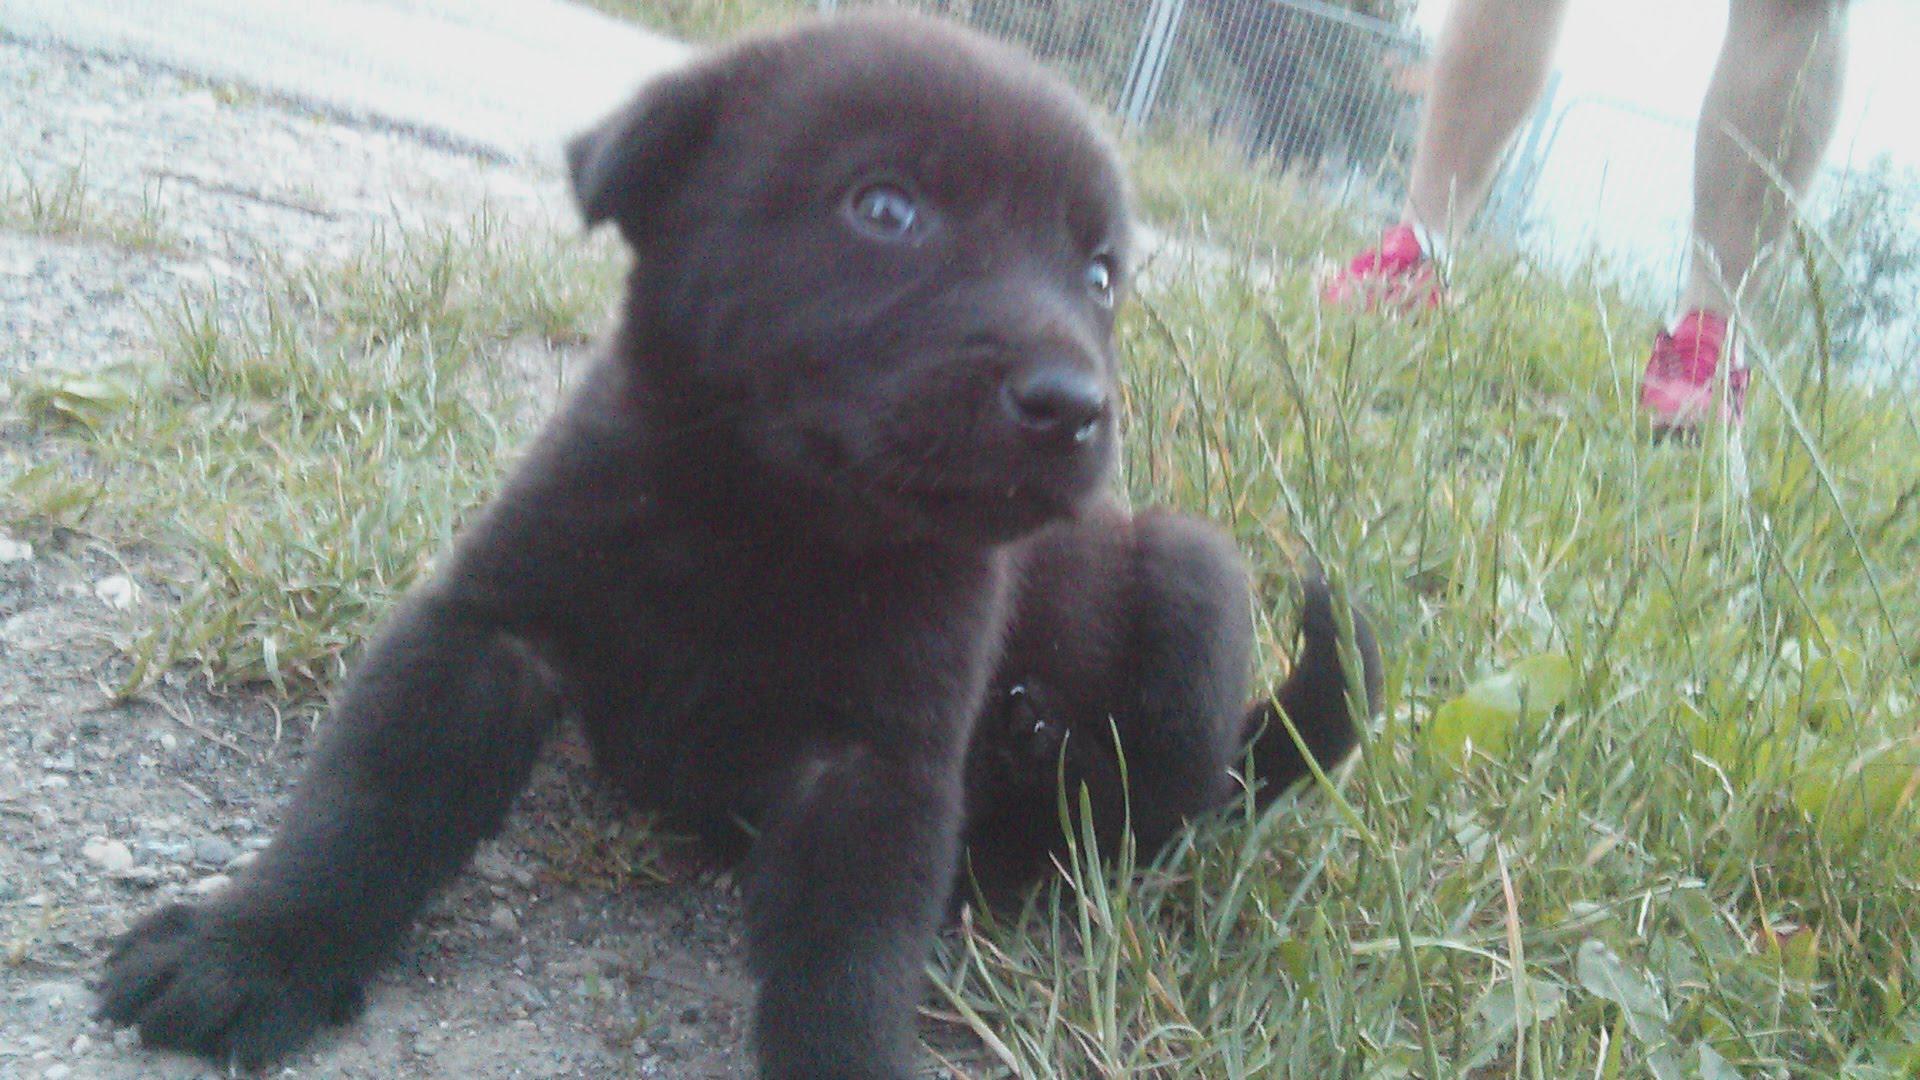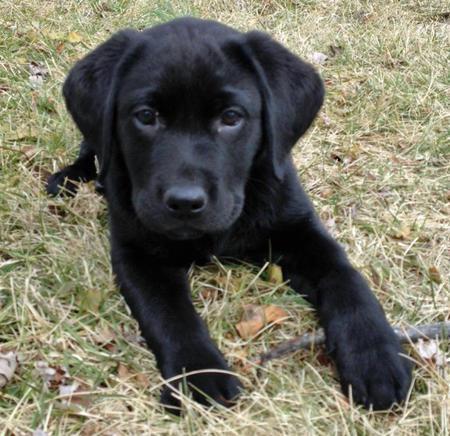The first image is the image on the left, the second image is the image on the right. Examine the images to the left and right. Is the description "Each image contains only one dog, and each dog is a black lab pup." accurate? Answer yes or no. Yes. The first image is the image on the left, the second image is the image on the right. Considering the images on both sides, is "The left image contains no more than one dog." valid? Answer yes or no. Yes. 